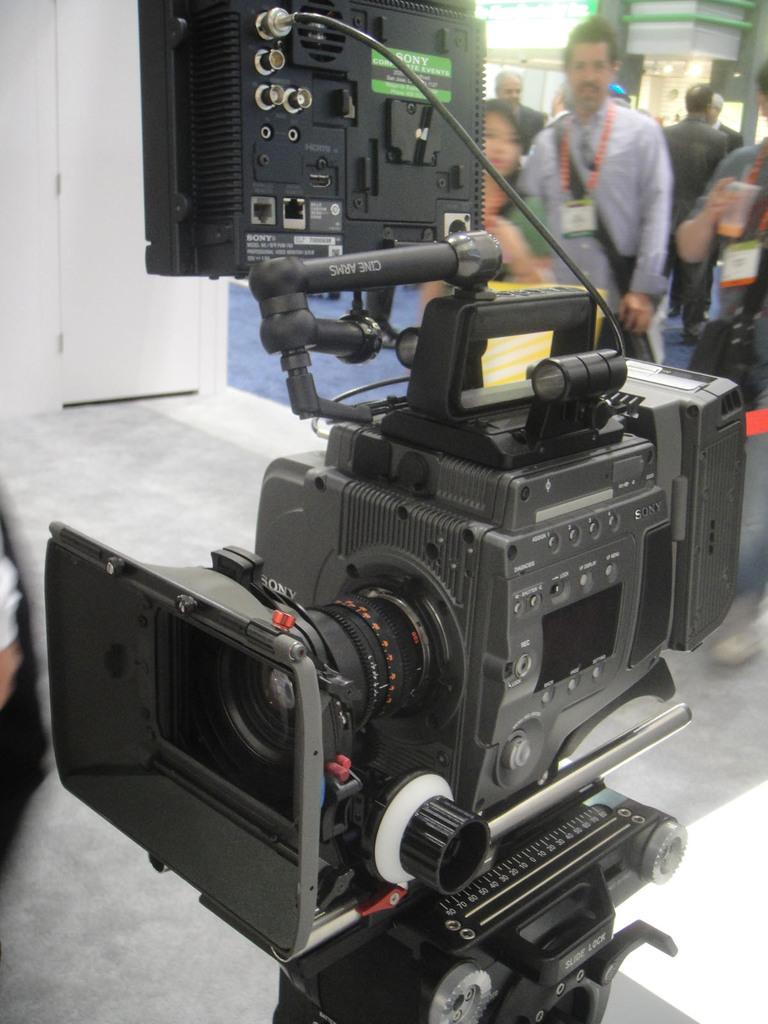What is the main object in the image? There is a camera in the image. What is connected to the camera? There is a system attached to the camera. Where are the camera and system located? The camera and system are on the floor. Are there any people visible in the image? Yes, there are persons visible in the top right of the image. What type of haircut is the laborer getting in the image? There is no laborer or haircut present in the image. What is the camera observing in the image? The image does not show the camera observing anything specific; it only shows the camera and system on the floor. 